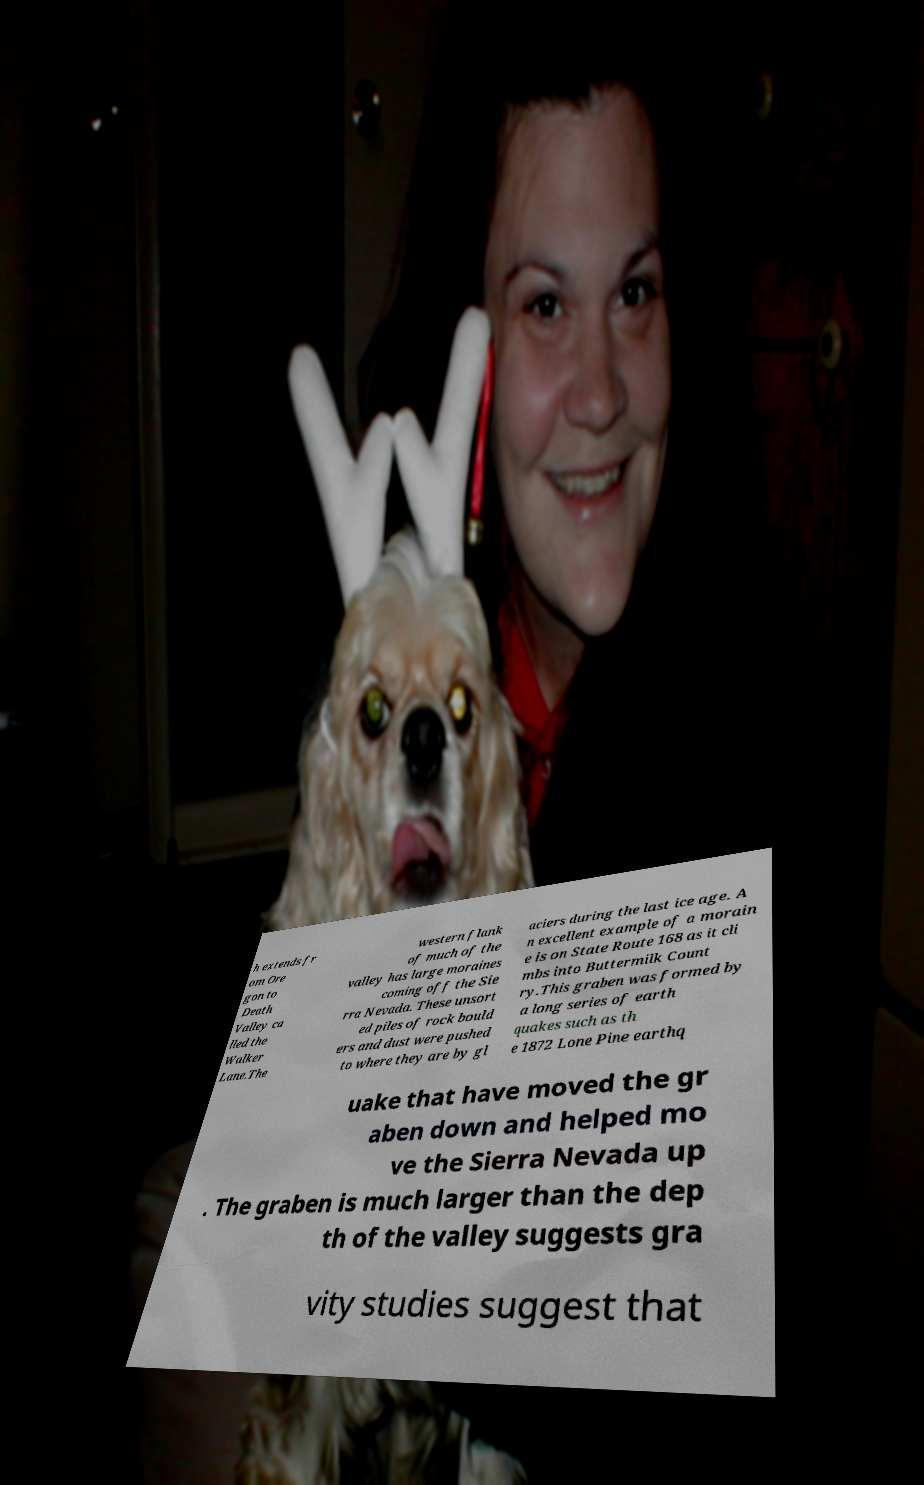Could you extract and type out the text from this image? h extends fr om Ore gon to Death Valley ca lled the Walker Lane.The western flank of much of the valley has large moraines coming off the Sie rra Nevada. These unsort ed piles of rock bould ers and dust were pushed to where they are by gl aciers during the last ice age. A n excellent example of a morain e is on State Route 168 as it cli mbs into Buttermilk Count ry.This graben was formed by a long series of earth quakes such as th e 1872 Lone Pine earthq uake that have moved the gr aben down and helped mo ve the Sierra Nevada up . The graben is much larger than the dep th of the valley suggests gra vity studies suggest that 